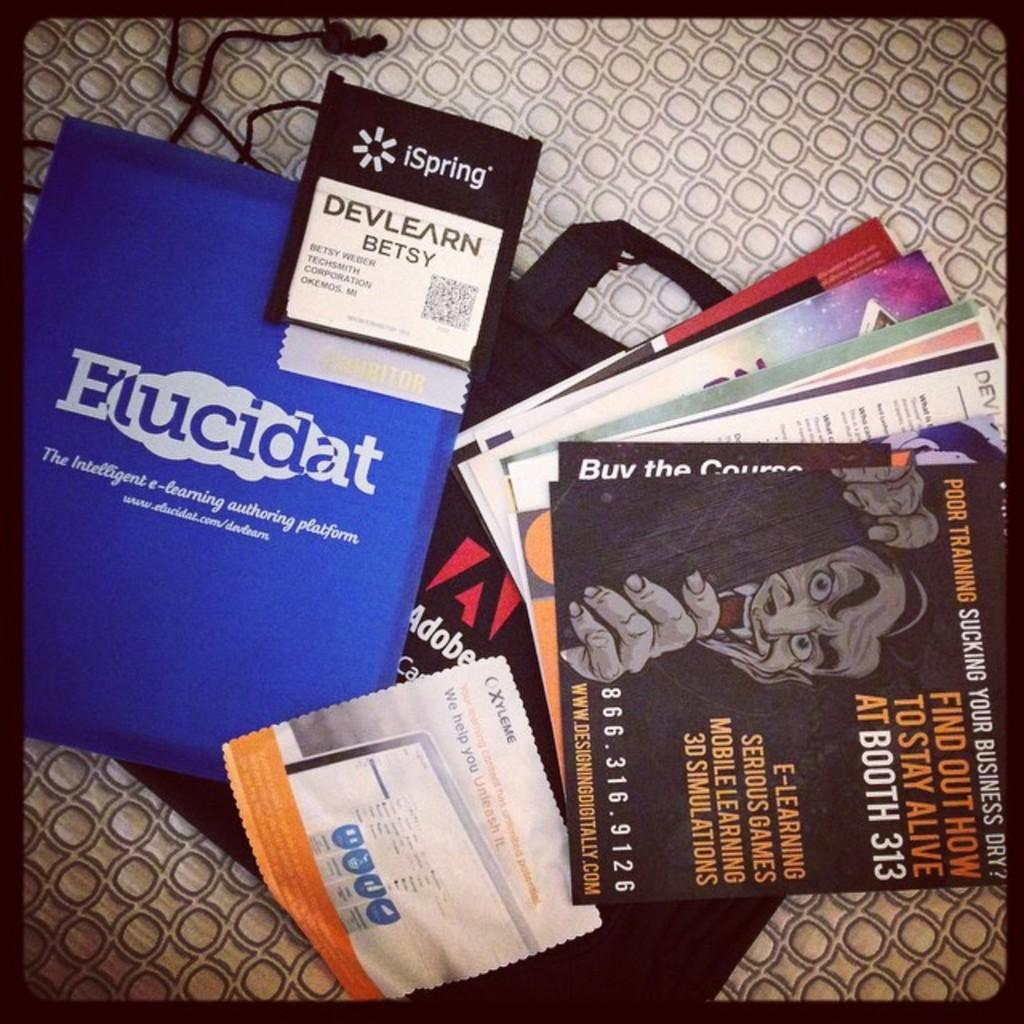<image>
Present a compact description of the photo's key features. A collection of books on a table with one titled Elucidat. 